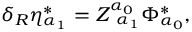<formula> <loc_0><loc_0><loc_500><loc_500>\delta _ { R } \eta _ { \alpha _ { 1 } } ^ { * } = Z _ { \, \alpha _ { 1 } } ^ { \alpha _ { 0 } } \Phi _ { \alpha _ { 0 } } ^ { * } ,</formula> 